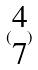<formula> <loc_0><loc_0><loc_500><loc_500>( \begin{matrix} 4 \\ 7 \end{matrix} )</formula> 